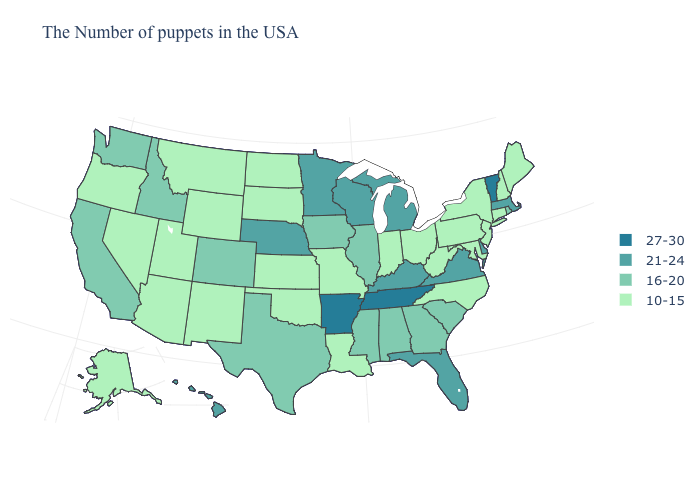Which states have the highest value in the USA?
Concise answer only. Vermont, Tennessee, Arkansas. Does New Hampshire have the same value as Nevada?
Give a very brief answer. Yes. Name the states that have a value in the range 21-24?
Quick response, please. Massachusetts, Delaware, Virginia, Florida, Michigan, Kentucky, Wisconsin, Minnesota, Nebraska, Hawaii. Does Vermont have the highest value in the USA?
Quick response, please. Yes. Name the states that have a value in the range 16-20?
Write a very short answer. Rhode Island, South Carolina, Georgia, Alabama, Illinois, Mississippi, Iowa, Texas, Colorado, Idaho, California, Washington. Does South Carolina have a lower value than Florida?
Concise answer only. Yes. Name the states that have a value in the range 10-15?
Short answer required. Maine, New Hampshire, Connecticut, New York, New Jersey, Maryland, Pennsylvania, North Carolina, West Virginia, Ohio, Indiana, Louisiana, Missouri, Kansas, Oklahoma, South Dakota, North Dakota, Wyoming, New Mexico, Utah, Montana, Arizona, Nevada, Oregon, Alaska. What is the value of New Hampshire?
Answer briefly. 10-15. Does the first symbol in the legend represent the smallest category?
Write a very short answer. No. How many symbols are there in the legend?
Be succinct. 4. Among the states that border Washington , which have the lowest value?
Give a very brief answer. Oregon. What is the value of Rhode Island?
Be succinct. 16-20. What is the highest value in states that border Tennessee?
Concise answer only. 27-30. Name the states that have a value in the range 16-20?
Give a very brief answer. Rhode Island, South Carolina, Georgia, Alabama, Illinois, Mississippi, Iowa, Texas, Colorado, Idaho, California, Washington. Name the states that have a value in the range 27-30?
Write a very short answer. Vermont, Tennessee, Arkansas. 